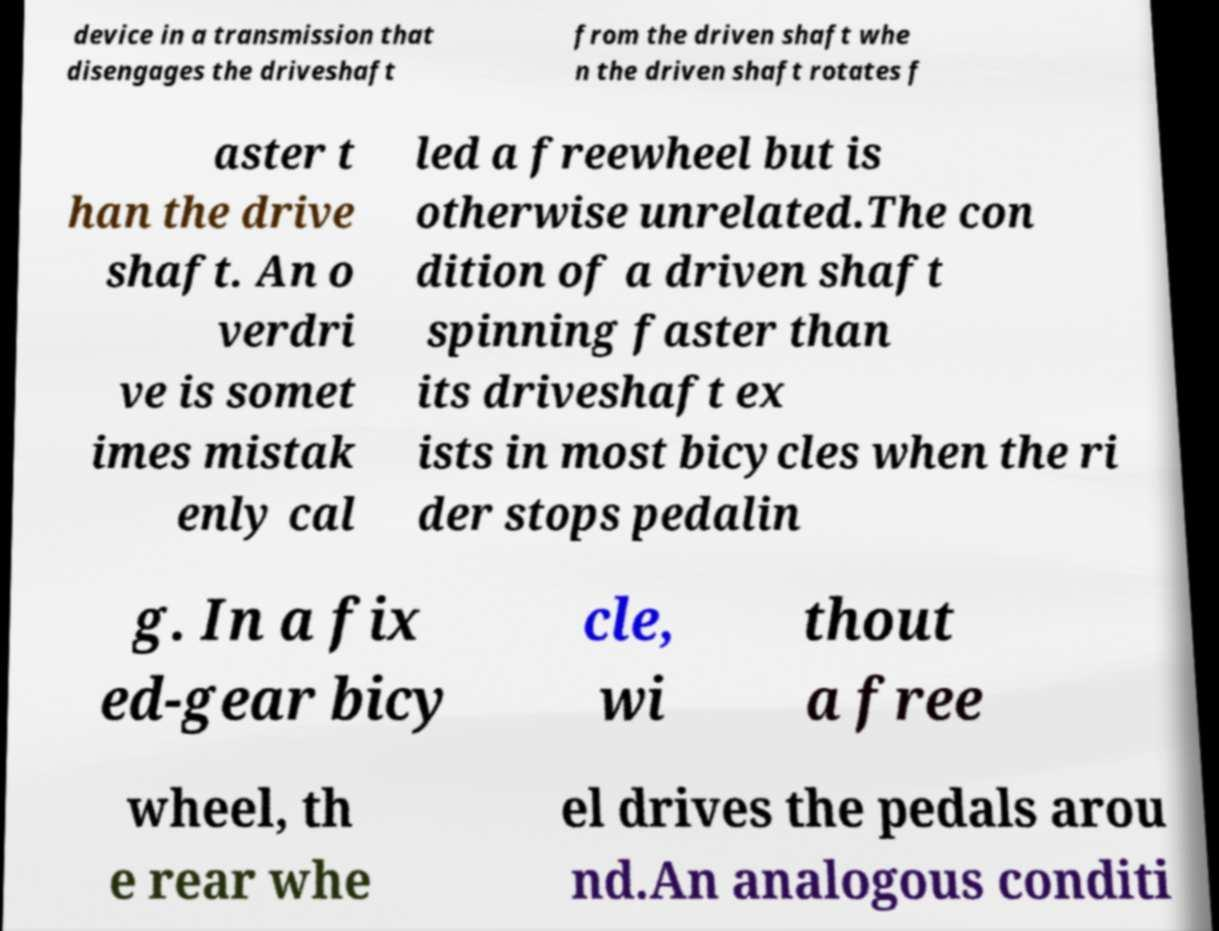I need the written content from this picture converted into text. Can you do that? device in a transmission that disengages the driveshaft from the driven shaft whe n the driven shaft rotates f aster t han the drive shaft. An o verdri ve is somet imes mistak enly cal led a freewheel but is otherwise unrelated.The con dition of a driven shaft spinning faster than its driveshaft ex ists in most bicycles when the ri der stops pedalin g. In a fix ed-gear bicy cle, wi thout a free wheel, th e rear whe el drives the pedals arou nd.An analogous conditi 